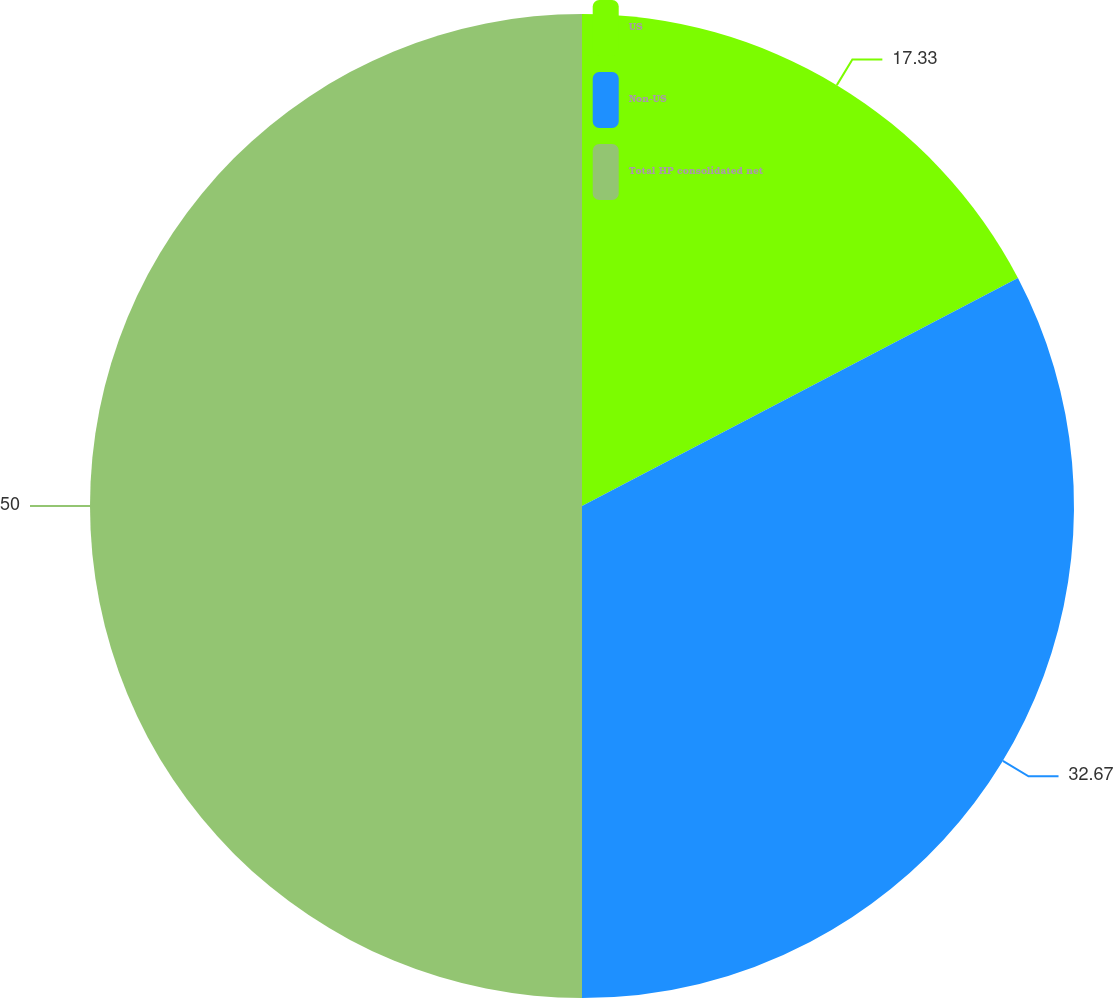<chart> <loc_0><loc_0><loc_500><loc_500><pie_chart><fcel>US<fcel>Non-US<fcel>Total HP consolidated net<nl><fcel>17.33%<fcel>32.67%<fcel>50.0%<nl></chart> 